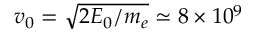<formula> <loc_0><loc_0><loc_500><loc_500>v _ { 0 } = \sqrt { 2 E _ { 0 } / m _ { e } } \simeq 8 \times 1 0 ^ { 9 }</formula> 